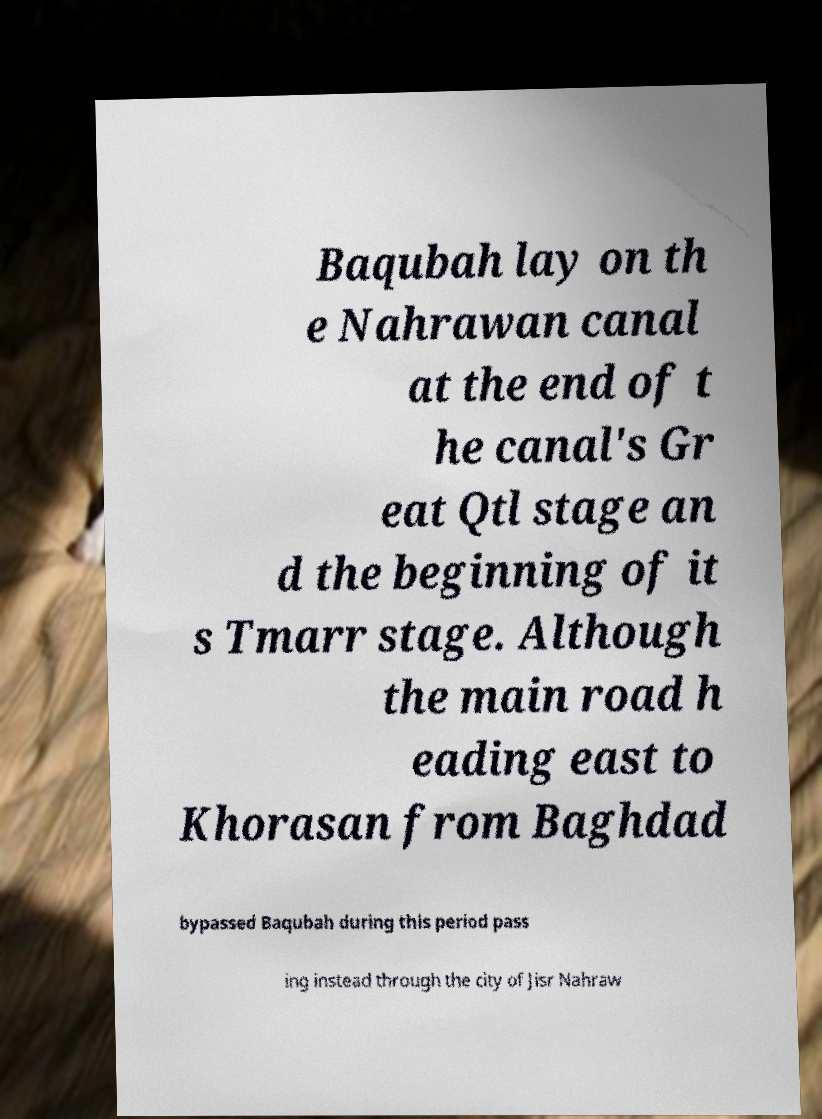Please read and relay the text visible in this image. What does it say? Baqubah lay on th e Nahrawan canal at the end of t he canal's Gr eat Qtl stage an d the beginning of it s Tmarr stage. Although the main road h eading east to Khorasan from Baghdad bypassed Baqubah during this period pass ing instead through the city of Jisr Nahraw 